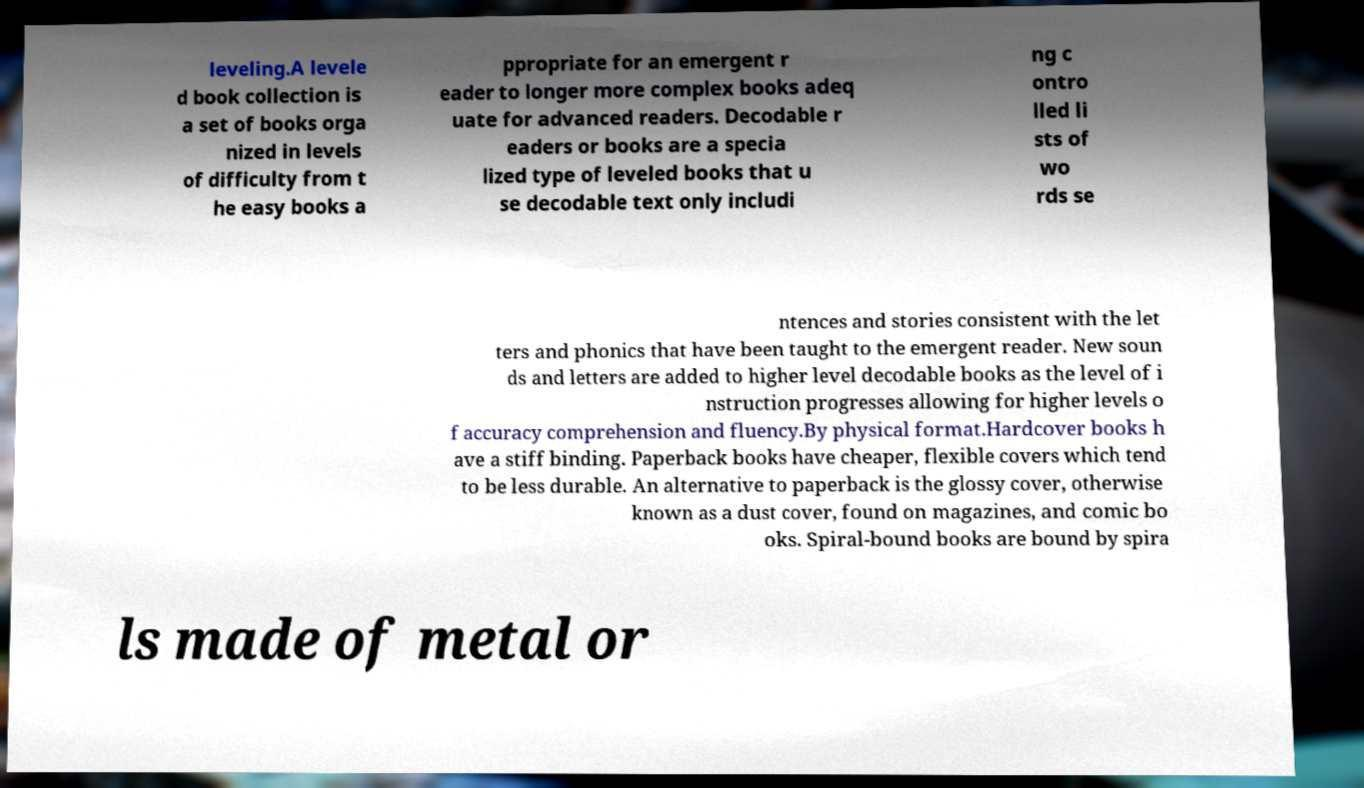Please identify and transcribe the text found in this image. leveling.A levele d book collection is a set of books orga nized in levels of difficulty from t he easy books a ppropriate for an emergent r eader to longer more complex books adeq uate for advanced readers. Decodable r eaders or books are a specia lized type of leveled books that u se decodable text only includi ng c ontro lled li sts of wo rds se ntences and stories consistent with the let ters and phonics that have been taught to the emergent reader. New soun ds and letters are added to higher level decodable books as the level of i nstruction progresses allowing for higher levels o f accuracy comprehension and fluency.By physical format.Hardcover books h ave a stiff binding. Paperback books have cheaper, flexible covers which tend to be less durable. An alternative to paperback is the glossy cover, otherwise known as a dust cover, found on magazines, and comic bo oks. Spiral-bound books are bound by spira ls made of metal or 